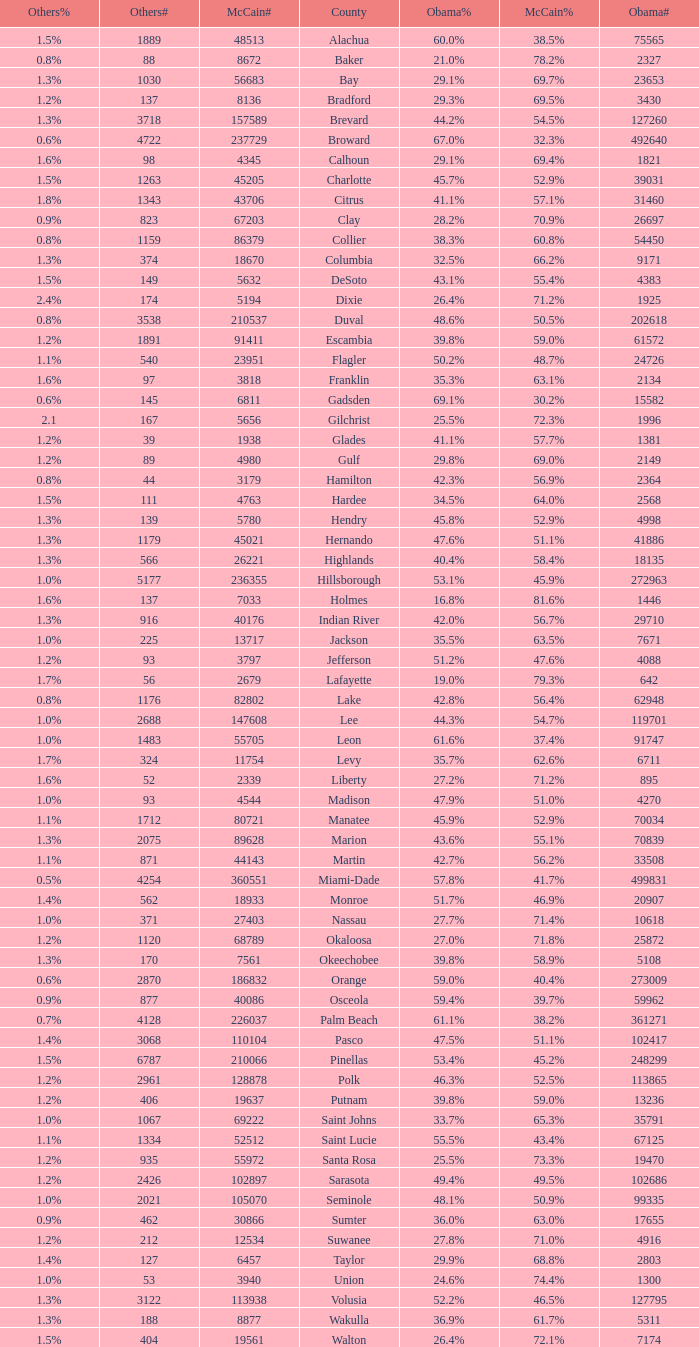What was the number of others votes in Columbia county? 374.0. 